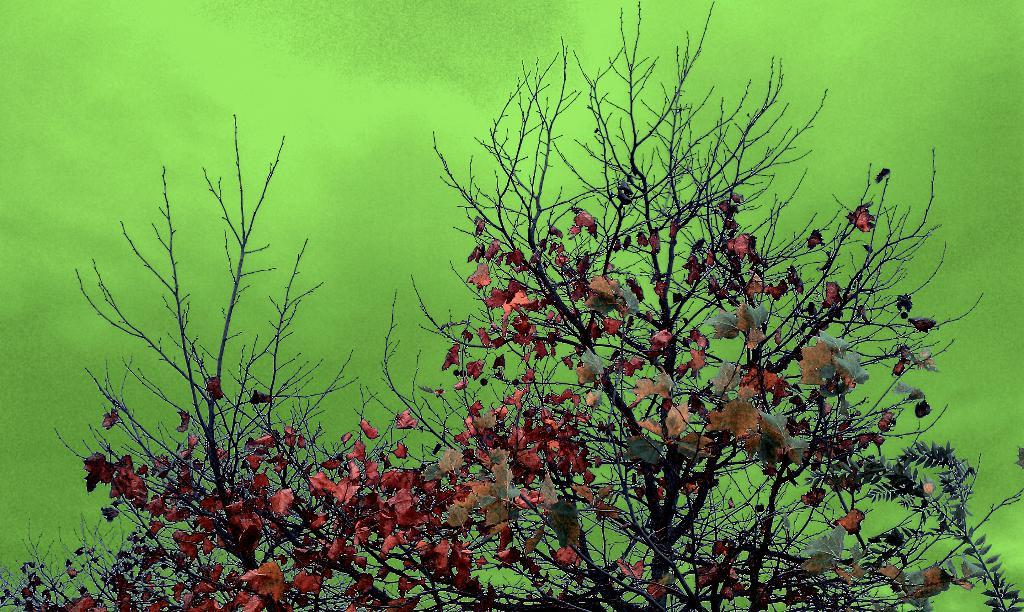What type of plant can be seen in the image? There is a tree in the image. What are the main parts of the tree visible in the image? The tree has stems, branches, and leaves. What color is the background of the image? The background of the image is green. What type of animal can be seen climbing the tree in the image? There is no animal visible in the image; it only shows a tree with stems, branches, and leaves. What kind of nut is being harvested from the tree in the image? There is no nut harvesting depicted in the image; it only shows a tree with stems, branches, and leaves. 